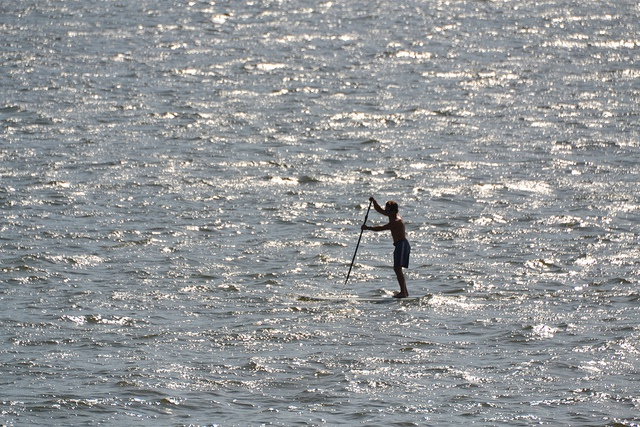Describe the objects in this image and their specific colors. I can see people in gray, black, and darkgray tones and surfboard in gray, darkgray, and lightgray tones in this image. 